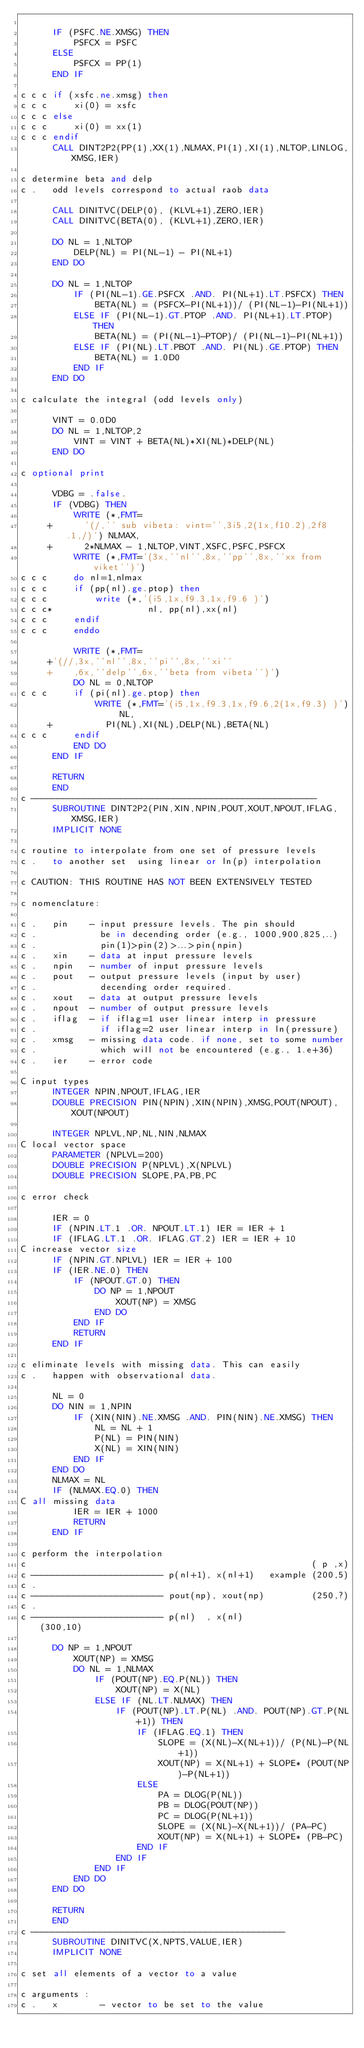Convert code to text. <code><loc_0><loc_0><loc_500><loc_500><_FORTRAN_>
      IF (PSFC.NE.XMSG) THEN
          PSFCX = PSFC
      ELSE
          PSFCX = PP(1)
      END IF

c c c if (xsfc.ne.xmsg) then
c c c     xi(0) = xsfc
c c c else
c c c     xi(0) = xx(1)
c c c endif
      CALL DINT2P2(PP(1),XX(1),NLMAX,PI(1),XI(1),NLTOP,LINLOG,XMSG,IER)

c determine beta and delp
c .   odd levels correspond to actual raob data

      CALL DINITVC(DELP(0), (KLVL+1),ZERO,IER)
      CALL DINITVC(BETA(0), (KLVL+1),ZERO,IER)

      DO NL = 1,NLTOP
          DELP(NL) = PI(NL-1) - PI(NL+1)
      END DO

      DO NL = 1,NLTOP
          IF (PI(NL-1).GE.PSFCX .AND. PI(NL+1).LT.PSFCX) THEN
              BETA(NL) = (PSFCX-PI(NL+1))/ (PI(NL-1)-PI(NL+1))
          ELSE IF (PI(NL-1).GT.PTOP .AND. PI(NL+1).LT.PTOP) THEN
              BETA(NL) = (PI(NL-1)-PTOP)/ (PI(NL-1)-PI(NL+1))
          ELSE IF (PI(NL).LT.PBOT .AND. PI(NL).GE.PTOP) THEN
              BETA(NL) = 1.0D0
          END IF
      END DO

c calculate the integral (odd levels only)

      VINT = 0.0D0
      DO NL = 1,NLTOP,2
          VINT = VINT + BETA(NL)*XI(NL)*DELP(NL)
      END DO

c optional print

      VDBG = .false.
      IF (VDBG) THEN
          WRITE (*,FMT=
     +      '(/,'' sub vibeta: vint='',3i5,2(1x,f10.2),2f8.1,/)') NLMAX,
     +      2*NLMAX - 1,NLTOP,VINT,XSFC,PSFC,PSFCX
          WRITE (*,FMT='(3x,''nl'',8x,''pp'',8x,''xx from viket'')')
c c c     do nl=1,nlmax
c c c     if (pp(nl).ge.ptop) then
c c c         write (*,'(i5,1x,f9.3,1x,f9.6 )')
c c c*                  nl, pp(nl),xx(nl)
c c c     endif
c c c     enddo

          WRITE (*,FMT=
     +'(//,3x,''nl'',8x,''pi'',8x,''xi''
     +    ,6x,''delp'',6x,''beta from vibeta'')')
          DO NL = 0,NLTOP
c c c     if (pi(nl).ge.ptop) then
              WRITE (*,FMT='(i5,1x,f9.3,1x,f9.6,2(1x,f9.3) )') NL,
     +          PI(NL),XI(NL),DELP(NL),BETA(NL)
c c c     endif
          END DO
      END IF

      RETURN
      END
c ------------------------------------------------------
      SUBROUTINE DINT2P2(PIN,XIN,NPIN,POUT,XOUT,NPOUT,IFLAG,XMSG,IER)
      IMPLICIT NONE

c routine to interpolate from one set of pressure levels
c .   to another set  using linear or ln(p) interpolation

c CAUTION: THIS ROUTINE HAS NOT BEEN EXTENSIVELY TESTED

c nomenclature:

c .   pin    - input pressure levels. The pin should
c .            be in decending order (e.g., 1000,900,825,..)
c .            pin(1)>pin(2)>...>pin(npin)
c .   xin    - data at input pressure levels
c .   npin   - number of input pressure levels
c .   pout   - output pressure levels (input by user)
c .            decending order required.
c .   xout   - data at output pressure levels
c .   npout  - number of output pressure levels
c .   iflag  - if iflag=1 user linear interp in pressure
c .            if iflag=2 user linear interp in ln(pressure)
c .   xmsg   - missing data code. if none, set to some number
c .            which will not be encountered (e.g., 1.e+36)
c .   ier    - error code

C input types
      INTEGER NPIN,NPOUT,IFLAG,IER
      DOUBLE PRECISION PIN(NPIN),XIN(NPIN),XMSG,POUT(NPOUT),XOUT(NPOUT)

      INTEGER NPLVL,NP,NL,NIN,NLMAX
C local vector space
      PARAMETER (NPLVL=200)
      DOUBLE PRECISION P(NPLVL),X(NPLVL)
      DOUBLE PRECISION SLOPE,PA,PB,PC

c error check

      IER = 0
      IF (NPIN.LT.1 .OR. NPOUT.LT.1) IER = IER + 1
      IF (IFLAG.LT.1 .OR. IFLAG.GT.2) IER = IER + 10
C increase vector size
      IF (NPIN.GT.NPLVL) IER = IER + 100
      IF (IER.NE.0) THEN
          IF (NPOUT.GT.0) THEN
              DO NP = 1,NPOUT
                  XOUT(NP) = XMSG
              END DO
          END IF
          RETURN
      END IF

c eliminate levels with missing data. This can easily
c .   happen with observational data.

      NL = 0
      DO NIN = 1,NPIN
          IF (XIN(NIN).NE.XMSG .AND. PIN(NIN).NE.XMSG) THEN
              NL = NL + 1
              P(NL) = PIN(NIN)
              X(NL) = XIN(NIN)
          END IF
      END DO
      NLMAX = NL
      IF (NLMAX.EQ.0) THEN
C all missing data
          IER = IER + 1000
          RETURN
      END IF

c perform the interpolation
c                                                      ( p ,x)
c ------------------------- p(nl+1), x(nl+1)   example (200,5)
c .
c ------------------------- pout(np), xout(np)         (250,?)
c .
c ------------------------- p(nl)  , x(nl)             (300,10)

      DO NP = 1,NPOUT
          XOUT(NP) = XMSG
          DO NL = 1,NLMAX
              IF (POUT(NP).EQ.P(NL)) THEN
                  XOUT(NP) = X(NL)
              ELSE IF (NL.LT.NLMAX) THEN
                  IF (POUT(NP).LT.P(NL) .AND. POUT(NP).GT.P(NL+1)) THEN
                      IF (IFLAG.EQ.1) THEN
                          SLOPE = (X(NL)-X(NL+1))/ (P(NL)-P(NL+1))
                          XOUT(NP) = X(NL+1) + SLOPE* (POUT(NP)-P(NL+1))
                      ELSE
                          PA = DLOG(P(NL))
                          PB = DLOG(POUT(NP))
                          PC = DLOG(P(NL+1))
                          SLOPE = (X(NL)-X(NL+1))/ (PA-PC)
                          XOUT(NP) = X(NL+1) + SLOPE* (PB-PC)
                      END IF
                  END IF
              END IF
          END DO
      END DO

      RETURN
      END
c ------------------------------------------------
      SUBROUTINE DINITVC(X,NPTS,VALUE,IER)
      IMPLICIT NONE

c set all elements of a vector to a value

c arguments :
c .   x        - vector to be set to the value</code> 